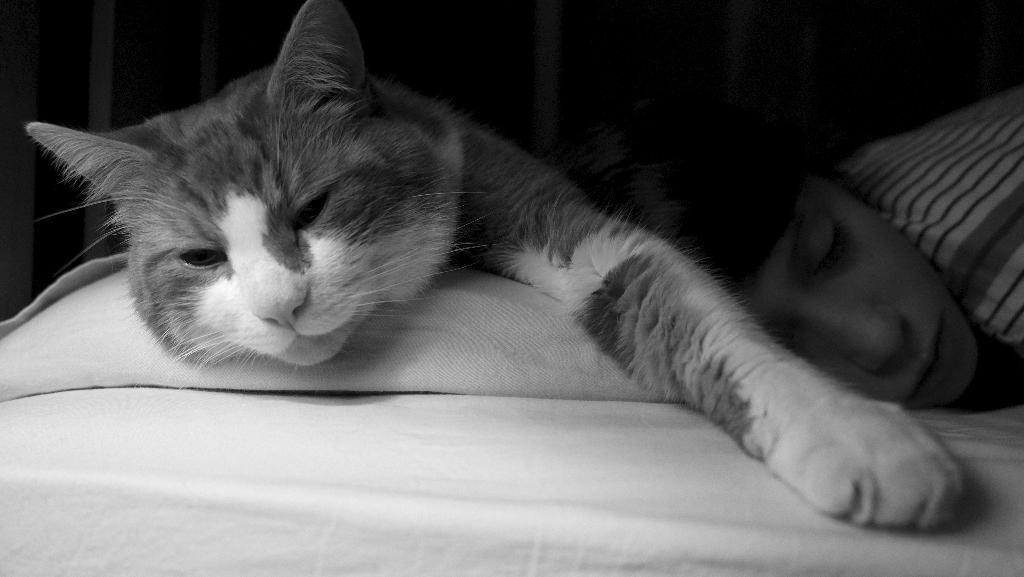Could you give a brief overview of what you see in this image? In the image we can see there is a cat who is lying on the bed with a person and the image is in black and white colour. 